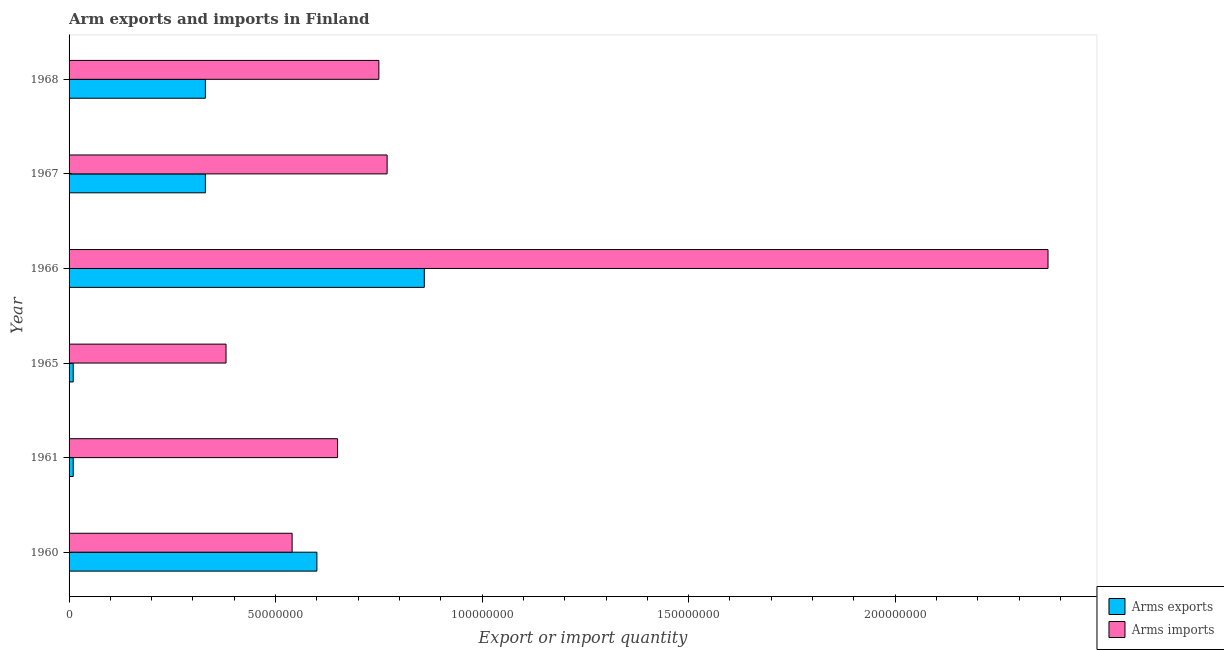How many different coloured bars are there?
Offer a terse response. 2. How many groups of bars are there?
Keep it short and to the point. 6. Are the number of bars per tick equal to the number of legend labels?
Ensure brevity in your answer.  Yes. Are the number of bars on each tick of the Y-axis equal?
Provide a succinct answer. Yes. How many bars are there on the 6th tick from the bottom?
Make the answer very short. 2. What is the label of the 3rd group of bars from the top?
Your answer should be compact. 1966. What is the arms exports in 1966?
Keep it short and to the point. 8.60e+07. Across all years, what is the maximum arms imports?
Give a very brief answer. 2.37e+08. Across all years, what is the minimum arms imports?
Keep it short and to the point. 3.80e+07. In which year was the arms exports maximum?
Offer a terse response. 1966. In which year was the arms imports minimum?
Offer a terse response. 1965. What is the total arms exports in the graph?
Provide a succinct answer. 2.14e+08. What is the difference between the arms imports in 1960 and that in 1965?
Your response must be concise. 1.60e+07. What is the difference between the arms exports in 1960 and the arms imports in 1961?
Ensure brevity in your answer.  -5.00e+06. What is the average arms imports per year?
Your answer should be very brief. 9.10e+07. In the year 1960, what is the difference between the arms exports and arms imports?
Your answer should be compact. 6.00e+06. In how many years, is the arms imports greater than 30000000 ?
Give a very brief answer. 6. What is the ratio of the arms exports in 1961 to that in 1965?
Your answer should be compact. 1. What is the difference between the highest and the second highest arms imports?
Ensure brevity in your answer.  1.60e+08. What is the difference between the highest and the lowest arms imports?
Your answer should be very brief. 1.99e+08. Is the sum of the arms exports in 1965 and 1968 greater than the maximum arms imports across all years?
Provide a succinct answer. No. What does the 1st bar from the top in 1961 represents?
Offer a terse response. Arms imports. What does the 1st bar from the bottom in 1960 represents?
Your answer should be very brief. Arms exports. How many bars are there?
Offer a terse response. 12. How many years are there in the graph?
Provide a short and direct response. 6. What is the difference between two consecutive major ticks on the X-axis?
Provide a short and direct response. 5.00e+07. Are the values on the major ticks of X-axis written in scientific E-notation?
Give a very brief answer. No. Where does the legend appear in the graph?
Make the answer very short. Bottom right. How many legend labels are there?
Offer a terse response. 2. How are the legend labels stacked?
Offer a very short reply. Vertical. What is the title of the graph?
Keep it short and to the point. Arm exports and imports in Finland. Does "Lowest 10% of population" appear as one of the legend labels in the graph?
Give a very brief answer. No. What is the label or title of the X-axis?
Offer a very short reply. Export or import quantity. What is the label or title of the Y-axis?
Provide a short and direct response. Year. What is the Export or import quantity in Arms exports in 1960?
Provide a short and direct response. 6.00e+07. What is the Export or import quantity of Arms imports in 1960?
Give a very brief answer. 5.40e+07. What is the Export or import quantity of Arms imports in 1961?
Provide a short and direct response. 6.50e+07. What is the Export or import quantity in Arms imports in 1965?
Offer a very short reply. 3.80e+07. What is the Export or import quantity in Arms exports in 1966?
Provide a short and direct response. 8.60e+07. What is the Export or import quantity in Arms imports in 1966?
Offer a terse response. 2.37e+08. What is the Export or import quantity of Arms exports in 1967?
Your response must be concise. 3.30e+07. What is the Export or import quantity of Arms imports in 1967?
Keep it short and to the point. 7.70e+07. What is the Export or import quantity of Arms exports in 1968?
Keep it short and to the point. 3.30e+07. What is the Export or import quantity in Arms imports in 1968?
Your answer should be compact. 7.50e+07. Across all years, what is the maximum Export or import quantity of Arms exports?
Provide a short and direct response. 8.60e+07. Across all years, what is the maximum Export or import quantity in Arms imports?
Give a very brief answer. 2.37e+08. Across all years, what is the minimum Export or import quantity in Arms imports?
Your answer should be compact. 3.80e+07. What is the total Export or import quantity of Arms exports in the graph?
Make the answer very short. 2.14e+08. What is the total Export or import quantity in Arms imports in the graph?
Give a very brief answer. 5.46e+08. What is the difference between the Export or import quantity of Arms exports in 1960 and that in 1961?
Provide a short and direct response. 5.90e+07. What is the difference between the Export or import quantity in Arms imports in 1960 and that in 1961?
Keep it short and to the point. -1.10e+07. What is the difference between the Export or import quantity in Arms exports in 1960 and that in 1965?
Your answer should be compact. 5.90e+07. What is the difference between the Export or import quantity of Arms imports in 1960 and that in 1965?
Offer a terse response. 1.60e+07. What is the difference between the Export or import quantity of Arms exports in 1960 and that in 1966?
Ensure brevity in your answer.  -2.60e+07. What is the difference between the Export or import quantity of Arms imports in 1960 and that in 1966?
Offer a very short reply. -1.83e+08. What is the difference between the Export or import quantity in Arms exports in 1960 and that in 1967?
Provide a short and direct response. 2.70e+07. What is the difference between the Export or import quantity of Arms imports in 1960 and that in 1967?
Your answer should be very brief. -2.30e+07. What is the difference between the Export or import quantity in Arms exports in 1960 and that in 1968?
Keep it short and to the point. 2.70e+07. What is the difference between the Export or import quantity of Arms imports in 1960 and that in 1968?
Provide a succinct answer. -2.10e+07. What is the difference between the Export or import quantity of Arms imports in 1961 and that in 1965?
Provide a short and direct response. 2.70e+07. What is the difference between the Export or import quantity in Arms exports in 1961 and that in 1966?
Your answer should be compact. -8.50e+07. What is the difference between the Export or import quantity in Arms imports in 1961 and that in 1966?
Provide a short and direct response. -1.72e+08. What is the difference between the Export or import quantity in Arms exports in 1961 and that in 1967?
Ensure brevity in your answer.  -3.20e+07. What is the difference between the Export or import quantity in Arms imports in 1961 and that in 1967?
Your answer should be compact. -1.20e+07. What is the difference between the Export or import quantity of Arms exports in 1961 and that in 1968?
Your response must be concise. -3.20e+07. What is the difference between the Export or import quantity of Arms imports in 1961 and that in 1968?
Give a very brief answer. -1.00e+07. What is the difference between the Export or import quantity of Arms exports in 1965 and that in 1966?
Give a very brief answer. -8.50e+07. What is the difference between the Export or import quantity of Arms imports in 1965 and that in 1966?
Keep it short and to the point. -1.99e+08. What is the difference between the Export or import quantity in Arms exports in 1965 and that in 1967?
Your answer should be very brief. -3.20e+07. What is the difference between the Export or import quantity of Arms imports in 1965 and that in 1967?
Your answer should be very brief. -3.90e+07. What is the difference between the Export or import quantity in Arms exports in 1965 and that in 1968?
Provide a succinct answer. -3.20e+07. What is the difference between the Export or import quantity in Arms imports in 1965 and that in 1968?
Your answer should be compact. -3.70e+07. What is the difference between the Export or import quantity of Arms exports in 1966 and that in 1967?
Offer a very short reply. 5.30e+07. What is the difference between the Export or import quantity in Arms imports in 1966 and that in 1967?
Your answer should be compact. 1.60e+08. What is the difference between the Export or import quantity of Arms exports in 1966 and that in 1968?
Offer a very short reply. 5.30e+07. What is the difference between the Export or import quantity of Arms imports in 1966 and that in 1968?
Offer a terse response. 1.62e+08. What is the difference between the Export or import quantity of Arms exports in 1967 and that in 1968?
Give a very brief answer. 0. What is the difference between the Export or import quantity of Arms imports in 1967 and that in 1968?
Keep it short and to the point. 2.00e+06. What is the difference between the Export or import quantity in Arms exports in 1960 and the Export or import quantity in Arms imports in 1961?
Offer a very short reply. -5.00e+06. What is the difference between the Export or import quantity of Arms exports in 1960 and the Export or import quantity of Arms imports in 1965?
Offer a very short reply. 2.20e+07. What is the difference between the Export or import quantity of Arms exports in 1960 and the Export or import quantity of Arms imports in 1966?
Your response must be concise. -1.77e+08. What is the difference between the Export or import quantity of Arms exports in 1960 and the Export or import quantity of Arms imports in 1967?
Make the answer very short. -1.70e+07. What is the difference between the Export or import quantity in Arms exports in 1960 and the Export or import quantity in Arms imports in 1968?
Provide a succinct answer. -1.50e+07. What is the difference between the Export or import quantity of Arms exports in 1961 and the Export or import quantity of Arms imports in 1965?
Your answer should be very brief. -3.70e+07. What is the difference between the Export or import quantity in Arms exports in 1961 and the Export or import quantity in Arms imports in 1966?
Offer a terse response. -2.36e+08. What is the difference between the Export or import quantity of Arms exports in 1961 and the Export or import quantity of Arms imports in 1967?
Your answer should be compact. -7.60e+07. What is the difference between the Export or import quantity in Arms exports in 1961 and the Export or import quantity in Arms imports in 1968?
Keep it short and to the point. -7.40e+07. What is the difference between the Export or import quantity of Arms exports in 1965 and the Export or import quantity of Arms imports in 1966?
Provide a succinct answer. -2.36e+08. What is the difference between the Export or import quantity of Arms exports in 1965 and the Export or import quantity of Arms imports in 1967?
Your answer should be compact. -7.60e+07. What is the difference between the Export or import quantity in Arms exports in 1965 and the Export or import quantity in Arms imports in 1968?
Your response must be concise. -7.40e+07. What is the difference between the Export or import quantity of Arms exports in 1966 and the Export or import quantity of Arms imports in 1967?
Give a very brief answer. 9.00e+06. What is the difference between the Export or import quantity in Arms exports in 1966 and the Export or import quantity in Arms imports in 1968?
Your response must be concise. 1.10e+07. What is the difference between the Export or import quantity of Arms exports in 1967 and the Export or import quantity of Arms imports in 1968?
Offer a terse response. -4.20e+07. What is the average Export or import quantity in Arms exports per year?
Your answer should be compact. 3.57e+07. What is the average Export or import quantity in Arms imports per year?
Your answer should be compact. 9.10e+07. In the year 1961, what is the difference between the Export or import quantity in Arms exports and Export or import quantity in Arms imports?
Provide a succinct answer. -6.40e+07. In the year 1965, what is the difference between the Export or import quantity of Arms exports and Export or import quantity of Arms imports?
Give a very brief answer. -3.70e+07. In the year 1966, what is the difference between the Export or import quantity in Arms exports and Export or import quantity in Arms imports?
Keep it short and to the point. -1.51e+08. In the year 1967, what is the difference between the Export or import quantity in Arms exports and Export or import quantity in Arms imports?
Make the answer very short. -4.40e+07. In the year 1968, what is the difference between the Export or import quantity in Arms exports and Export or import quantity in Arms imports?
Make the answer very short. -4.20e+07. What is the ratio of the Export or import quantity in Arms exports in 1960 to that in 1961?
Keep it short and to the point. 60. What is the ratio of the Export or import quantity in Arms imports in 1960 to that in 1961?
Make the answer very short. 0.83. What is the ratio of the Export or import quantity of Arms exports in 1960 to that in 1965?
Your answer should be very brief. 60. What is the ratio of the Export or import quantity of Arms imports in 1960 to that in 1965?
Provide a short and direct response. 1.42. What is the ratio of the Export or import quantity in Arms exports in 1960 to that in 1966?
Offer a very short reply. 0.7. What is the ratio of the Export or import quantity in Arms imports in 1960 to that in 1966?
Provide a succinct answer. 0.23. What is the ratio of the Export or import quantity of Arms exports in 1960 to that in 1967?
Make the answer very short. 1.82. What is the ratio of the Export or import quantity of Arms imports in 1960 to that in 1967?
Your response must be concise. 0.7. What is the ratio of the Export or import quantity in Arms exports in 1960 to that in 1968?
Provide a short and direct response. 1.82. What is the ratio of the Export or import quantity of Arms imports in 1960 to that in 1968?
Ensure brevity in your answer.  0.72. What is the ratio of the Export or import quantity in Arms exports in 1961 to that in 1965?
Your response must be concise. 1. What is the ratio of the Export or import quantity in Arms imports in 1961 to that in 1965?
Ensure brevity in your answer.  1.71. What is the ratio of the Export or import quantity in Arms exports in 1961 to that in 1966?
Ensure brevity in your answer.  0.01. What is the ratio of the Export or import quantity of Arms imports in 1961 to that in 1966?
Provide a short and direct response. 0.27. What is the ratio of the Export or import quantity in Arms exports in 1961 to that in 1967?
Give a very brief answer. 0.03. What is the ratio of the Export or import quantity of Arms imports in 1961 to that in 1967?
Ensure brevity in your answer.  0.84. What is the ratio of the Export or import quantity of Arms exports in 1961 to that in 1968?
Offer a very short reply. 0.03. What is the ratio of the Export or import quantity of Arms imports in 1961 to that in 1968?
Make the answer very short. 0.87. What is the ratio of the Export or import quantity in Arms exports in 1965 to that in 1966?
Your response must be concise. 0.01. What is the ratio of the Export or import quantity of Arms imports in 1965 to that in 1966?
Your answer should be compact. 0.16. What is the ratio of the Export or import quantity of Arms exports in 1965 to that in 1967?
Your response must be concise. 0.03. What is the ratio of the Export or import quantity of Arms imports in 1965 to that in 1967?
Ensure brevity in your answer.  0.49. What is the ratio of the Export or import quantity of Arms exports in 1965 to that in 1968?
Provide a succinct answer. 0.03. What is the ratio of the Export or import quantity in Arms imports in 1965 to that in 1968?
Your answer should be very brief. 0.51. What is the ratio of the Export or import quantity of Arms exports in 1966 to that in 1967?
Offer a terse response. 2.61. What is the ratio of the Export or import quantity of Arms imports in 1966 to that in 1967?
Your answer should be compact. 3.08. What is the ratio of the Export or import quantity of Arms exports in 1966 to that in 1968?
Give a very brief answer. 2.61. What is the ratio of the Export or import quantity of Arms imports in 1966 to that in 1968?
Offer a very short reply. 3.16. What is the ratio of the Export or import quantity in Arms exports in 1967 to that in 1968?
Your answer should be compact. 1. What is the ratio of the Export or import quantity of Arms imports in 1967 to that in 1968?
Make the answer very short. 1.03. What is the difference between the highest and the second highest Export or import quantity of Arms exports?
Your answer should be very brief. 2.60e+07. What is the difference between the highest and the second highest Export or import quantity of Arms imports?
Keep it short and to the point. 1.60e+08. What is the difference between the highest and the lowest Export or import quantity of Arms exports?
Ensure brevity in your answer.  8.50e+07. What is the difference between the highest and the lowest Export or import quantity in Arms imports?
Your response must be concise. 1.99e+08. 